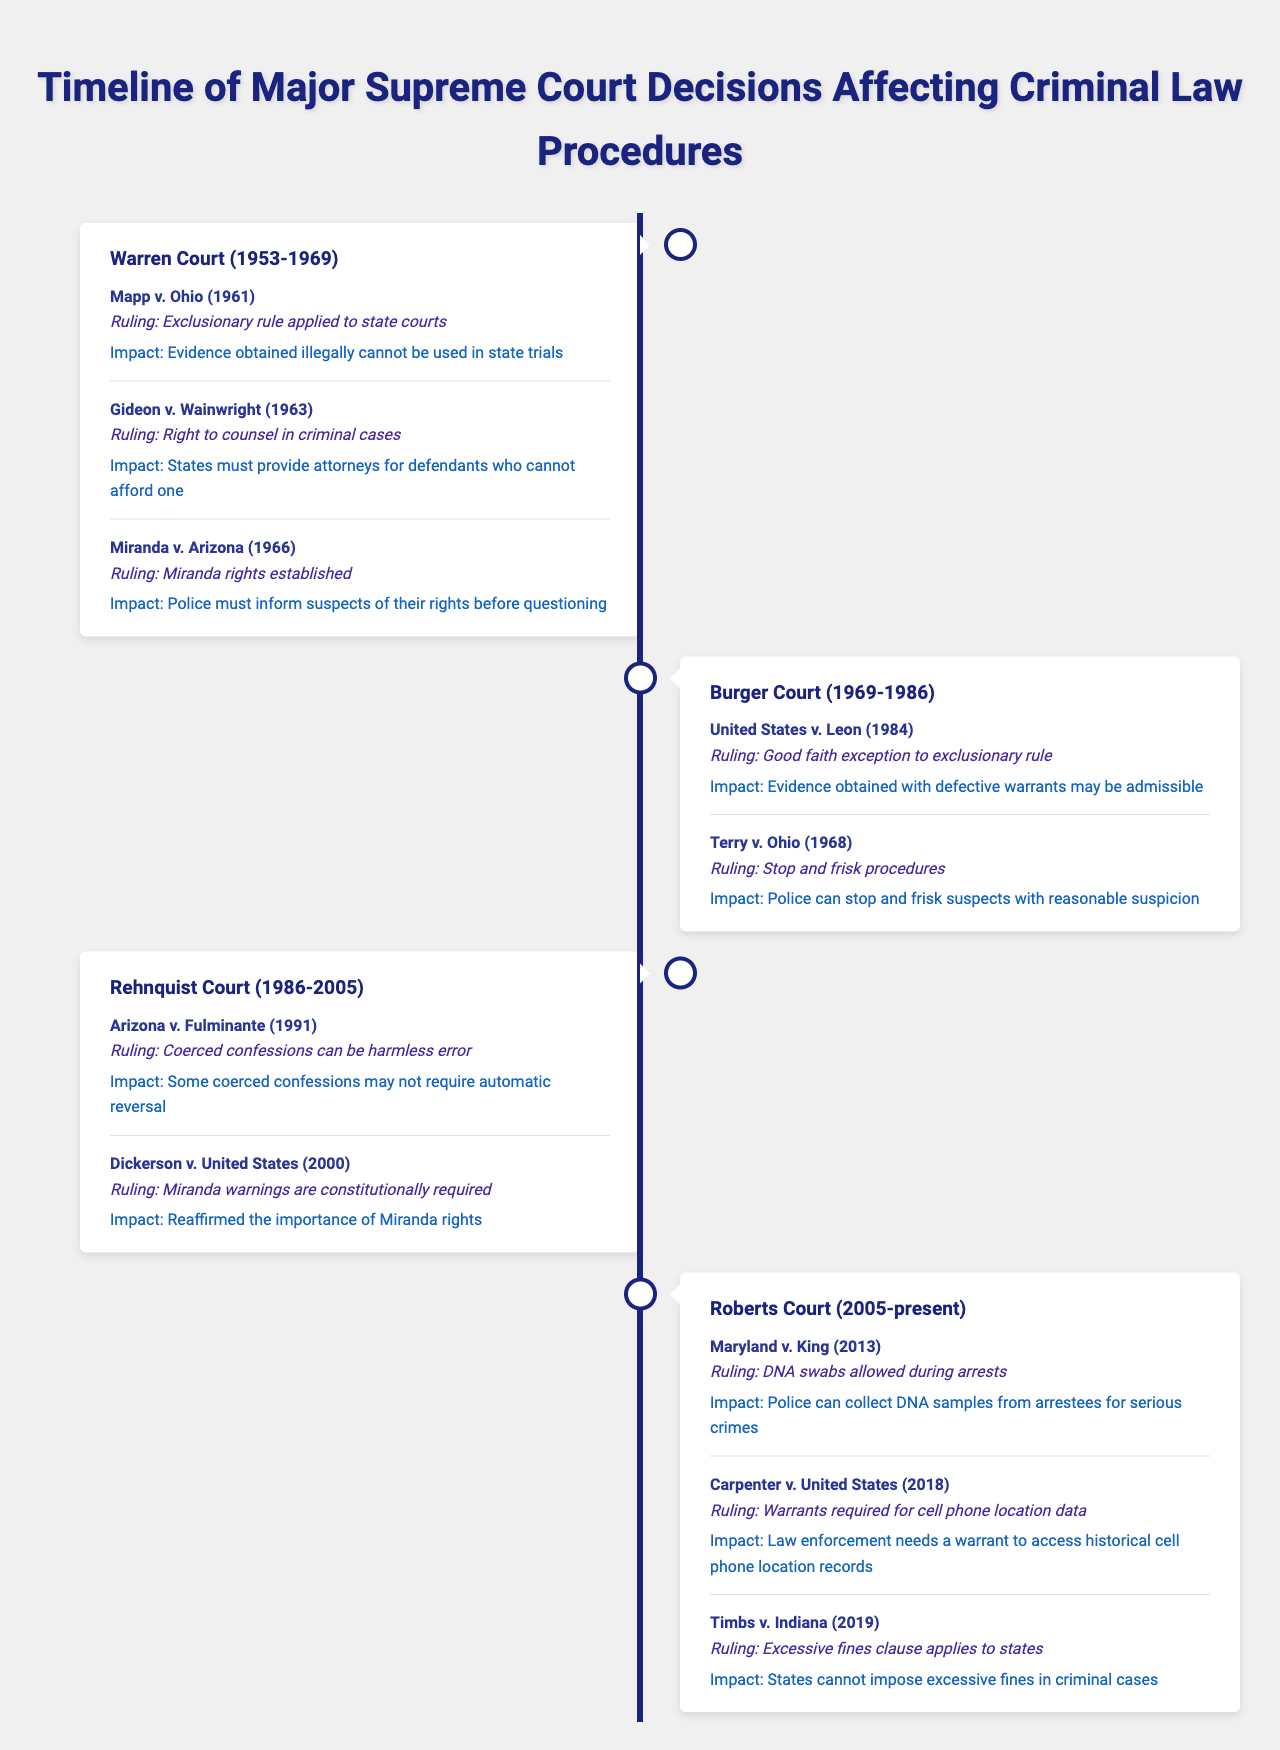What is the ruling in Mapp v. Ohio? The table states that the ruling in Mapp v. Ohio is the application of the exclusionary rule to state courts.
Answer: Exclusionary rule applied to state courts Which Supreme Court era included the case Gideon v. Wainwright? The entry for Gideon v. Wainwright indicates it was within the Warren Court era, which lasted from 1953 to 1969.
Answer: Warren Court How many key decisions were made during the Roberts Court era? The Roberts Court era has three key decisions listed: Maryland v. King, Carpenter v. United States, and Timbs v. Indiana.
Answer: Three key decisions What does the ruling in Terry v. Ohio allow? The ruling in Terry v. Ohio allows police to stop and frisk suspects if there is reasonable suspicion.
Answer: Police can stop and frisk suspects with reasonable suspicion Is the good faith exception to the exclusionary rule affirmed in the Rehnquist Court? No, the good faith exception to the exclusionary rule is established during the Burger Court era, specifically in United States v. Leon (1984).
Answer: No Which case reaffirmed the importance of Miranda rights? The case Dickerson v. United States, decided in 2000 during the Rehnquist Court, reaffirmed the importance of Miranda rights.
Answer: Dickerson v. United States Did the Burger Court era make any decisions regarding stop and frisk procedures? Yes, the Burger Court era made the decision in Terry v. Ohio, which established stop and frisk procedures.
Answer: Yes What is the impact of the ruling in Maryland v. King? The impact of Maryland v. King allows police to collect DNA samples from individuals arrested for serious crimes.
Answer: Police can collect DNA samples from arrestees How many eras are listed in the table? The table contains four major eras: Warren Court, Burger Court, Rehnquist Court, and Roberts Court.
Answer: Four eras What is the common theme across the rulings during the Warren Court? The common theme during the Warren Court is the protection of defendants' rights in criminal procedures, including the right to counsel and the exclusion of illegally obtained evidence.
Answer: Protection of defendants' rights 